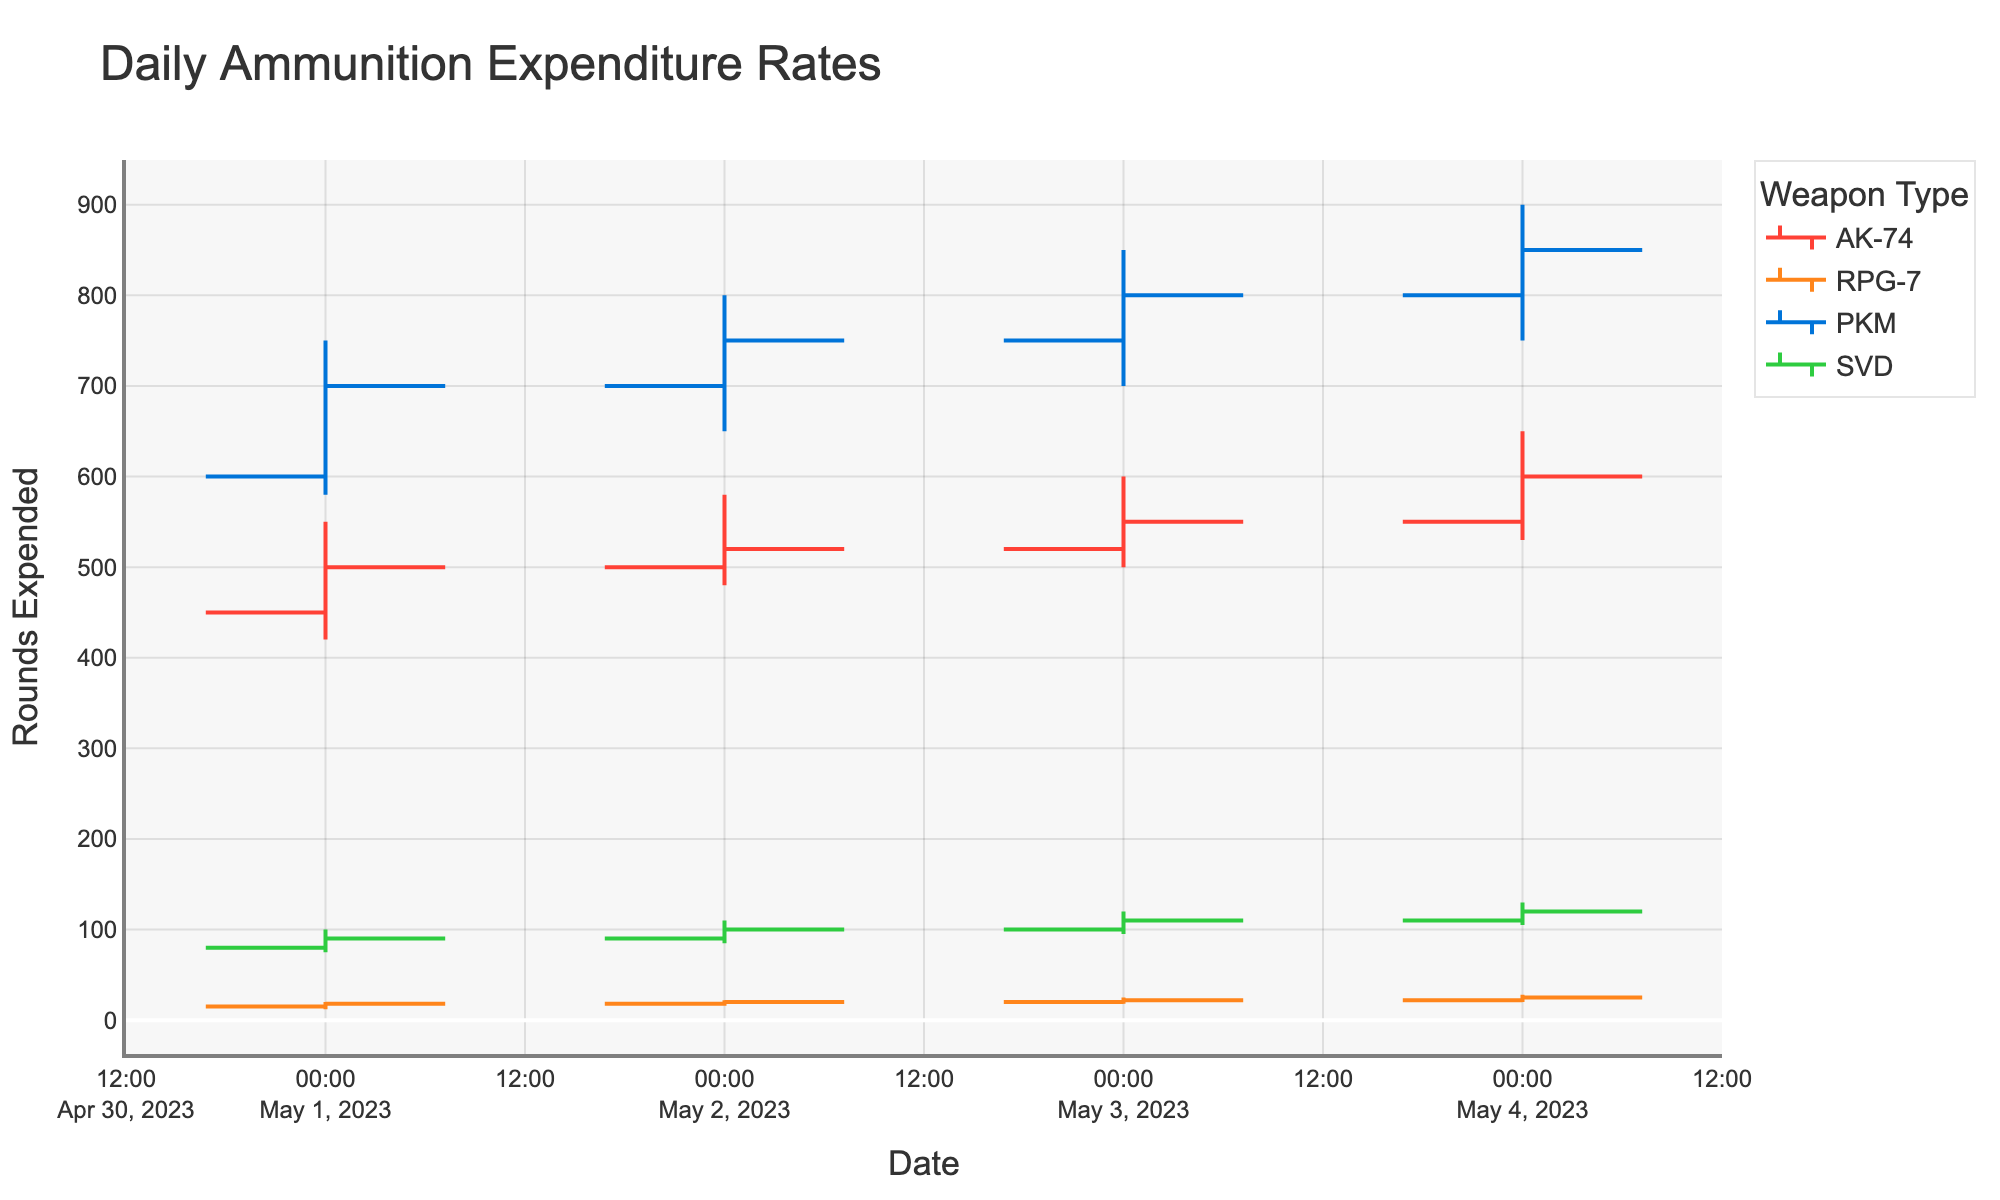what is the title of the chart? The title of the chart is located at the top and is usually the largest text on the chart.
Answer: Daily Ammunition Expenditure Rates how many different weapon types are shown in the chart? The legend on the right side of the chart lists all the weapon types included.
Answer: Four on which date did the AK-74 have the highest closing ammunition expenditure? By looking at the highest close value for AK-74 across all dates on the chart, we see it is 600 on May 4, 2023.
Answer: May 4, 2023 how many points of data are there for the PKM? We can count the number of OHLC bars associated with PKM on the chart.
Answer: Four which weapon had the lowest high value during the exercise period? By comparing the high values of all weapons over all dates, RPG-7 has the lowest high value at 20 on May 1, 2023.
Answer: RPG-7 which day shows the steepest increase in ammunition expenditure for the AK-74? By examining the difference between open and close price each day for AK-74, the largest increase is 50 (from 550 to 600) on May 4, 2023.
Answer: May 4, 2023 on which date did the RPG-7 have the lowest low value and what was it? By evaluating the low values for RPG-7 on different dates, the lowest is 12 on May 1, 2023.
Answer: May 1, 2023, 12 what is the total closing value for the SVD over all exercise dates? By adding up the close values for SVD on each date: 90 + 100 + 110 + 120 = 420.
Answer: 420 which weapon shows a consistent increase in closing value over all dates? By checking the closing values of each weapon over dates, only SVD shows an increase on each day.
Answer: SVD what are the colors used to represent AK-74 and PKM? The colors can be found by looking at the legend. AK-74 is red and PKM is blue.
Answer: Red and blue 